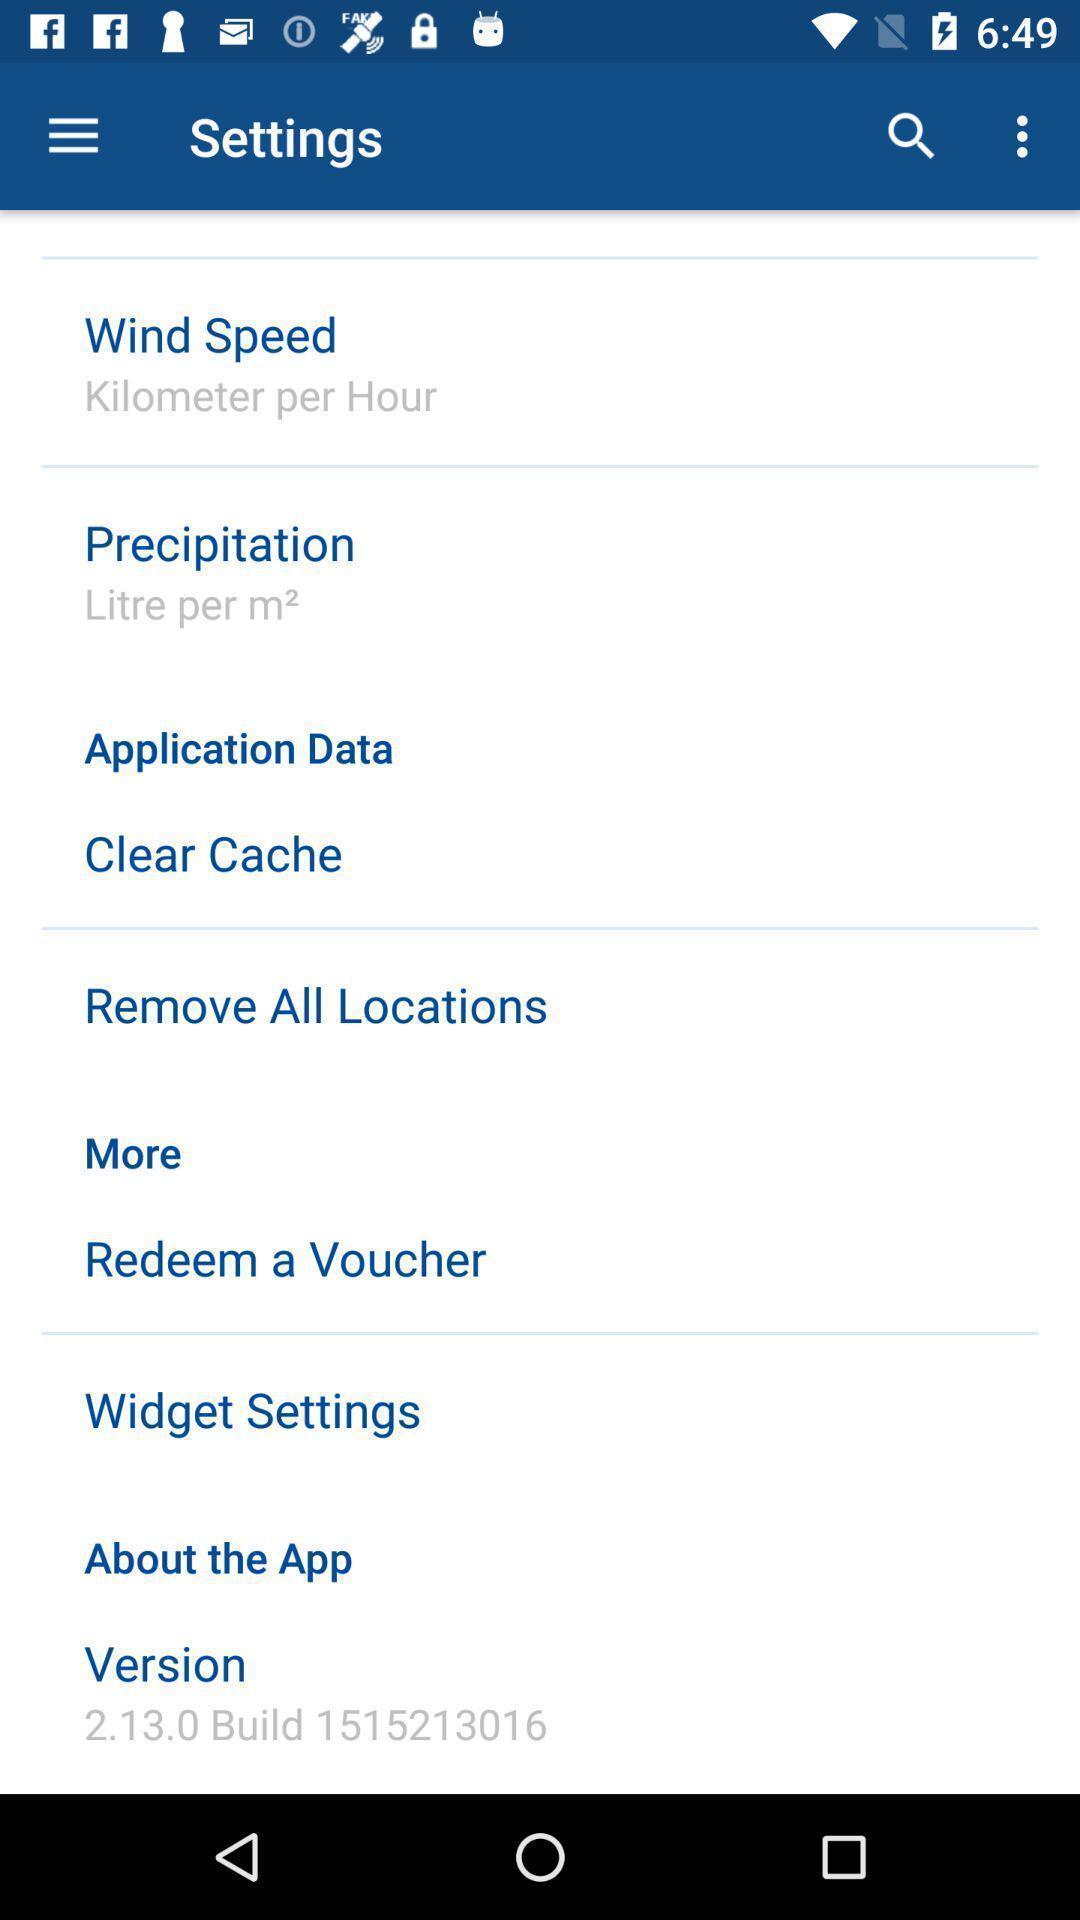Describe the key features of this screenshot. Setting page displaying the various options. 